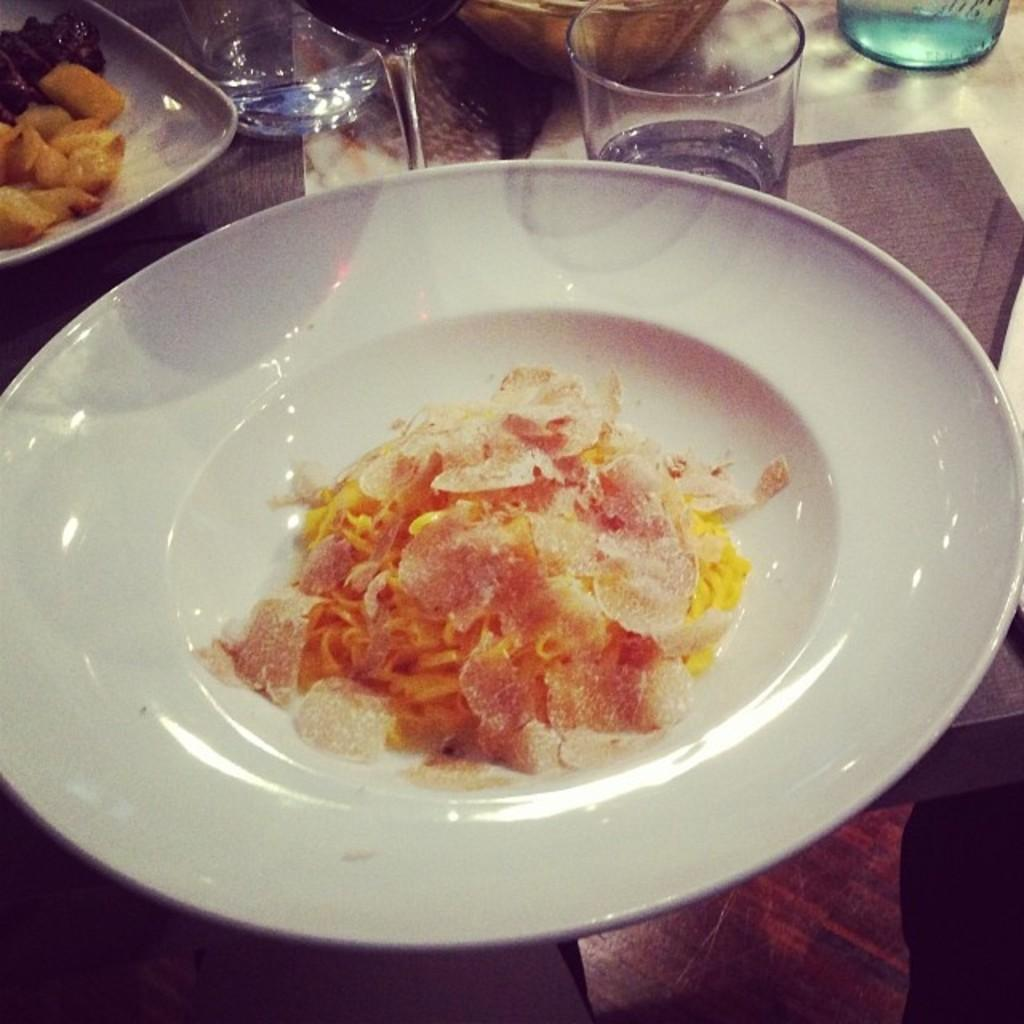What can be seen on the plates in the image? There are food items on plates in the image. What else is present on the table in the image? There are glasses and an object on the table. Reasoning: Leting: Let's think step by step in order to produce the conversation. We start by identifying the main subjects in the image, which are the food items on plates. Then, we expand the conversation to include other items that are also visible, such as glasses and an unspecified object on the table. Each question is designed to elicit a specific detail about the image that is known from the provided facts. Absurd Question/Answer: How many oranges are being cooked by the chef in the image? There is no chef or oranges present in the image. What type of leaf can be seen falling from the tree in the image? There is no tree or leaf present in the image. What type of leaf can be seen falling from the tree in the image? There is no tree or leaf present in the image. How many oranges are being cooked by the chef in the image? There is no chef or oranges present in the image. 